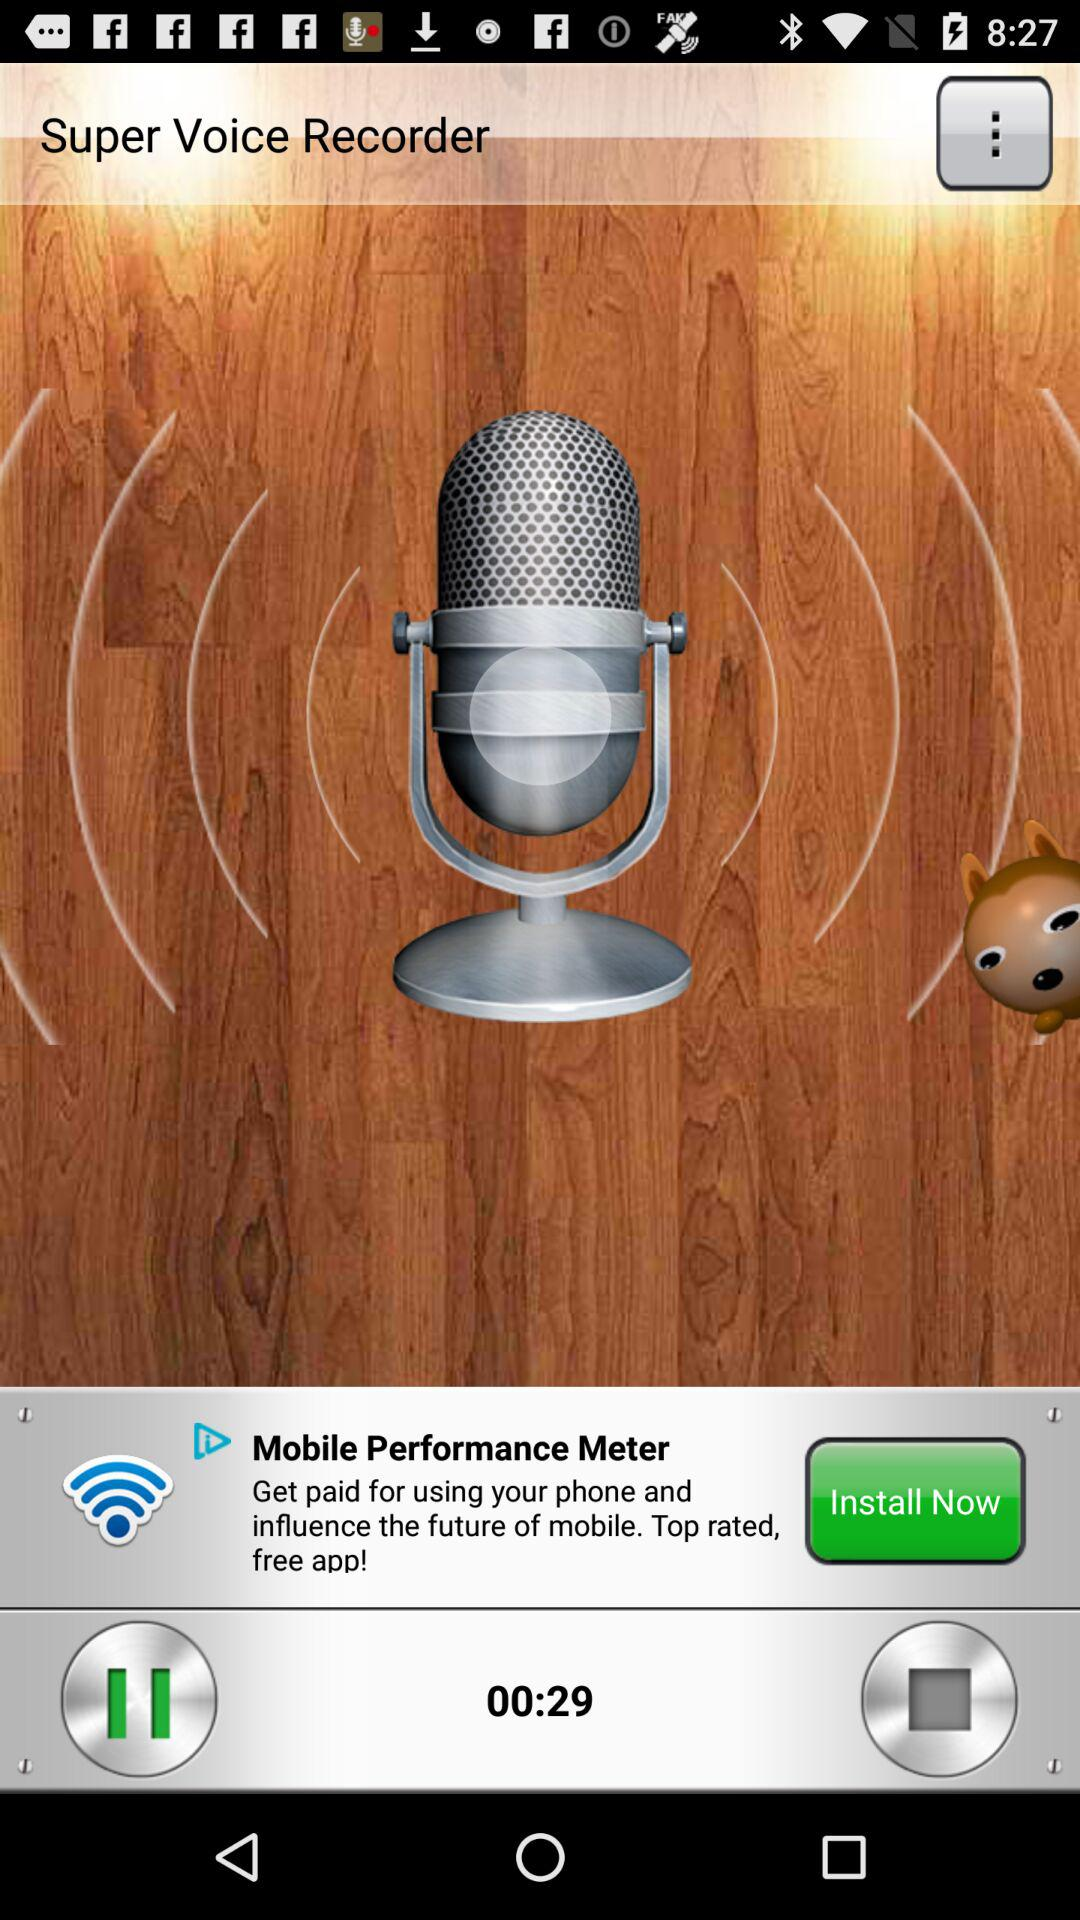What is the duration of super voice recorder? The duration is 29 seconds. 